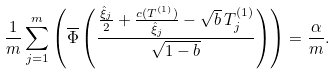Convert formula to latex. <formula><loc_0><loc_0><loc_500><loc_500>\frac { 1 } { m } \sum _ { j = 1 } ^ { m } \left ( \overline { \Phi } \left ( \frac { \frac { \hat { \xi } _ { j } } { 2 } + \frac { c ( T ^ { ( 1 ) } ) } { \hat { \xi } _ { j } } - \sqrt { b } \, T _ { j } ^ { ( 1 ) } } { \sqrt { 1 - b } } \right ) \right ) = \frac { \alpha } { m } .</formula> 